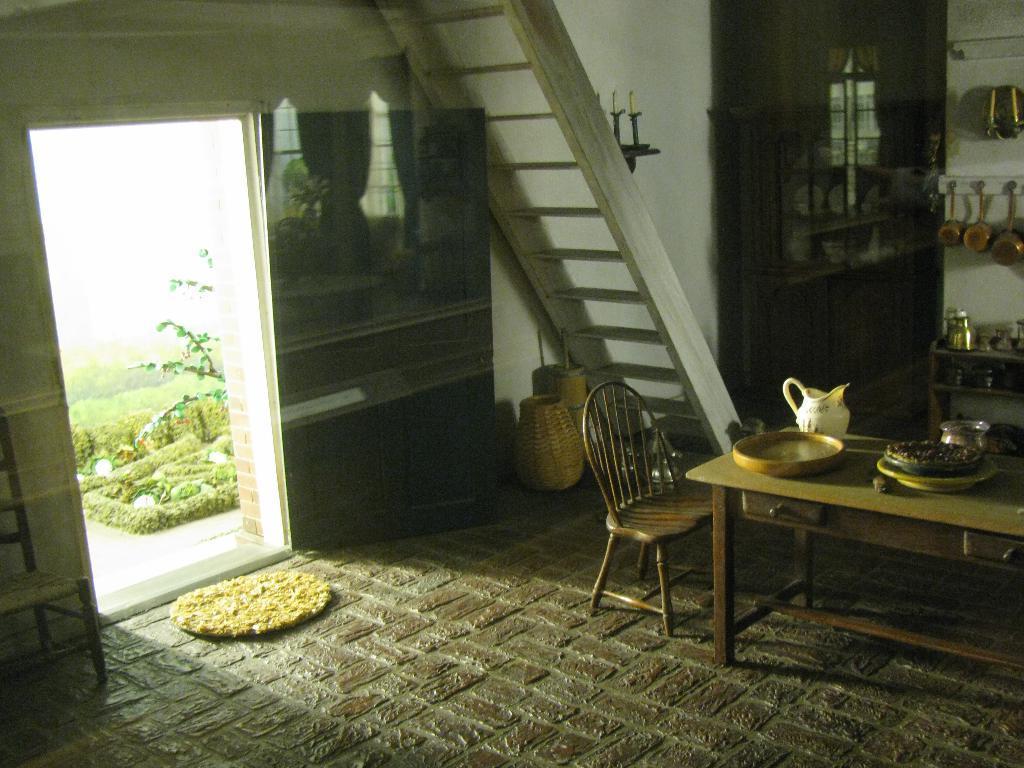Can you describe this image briefly? In this picture I can see a ceramic jug, plates, a bowl and some other items on the table, there are chairs, a mat, a ladder, candles with a candle stand, there are some items in the cupboard, there are some items in and on the rack, there are utensils hanging to the stand which is attached to the wall, and in the background there is grass, plants , tree. 